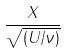Convert formula to latex. <formula><loc_0><loc_0><loc_500><loc_500>\frac { X } { \sqrt { ( U / \nu ) } }</formula> 